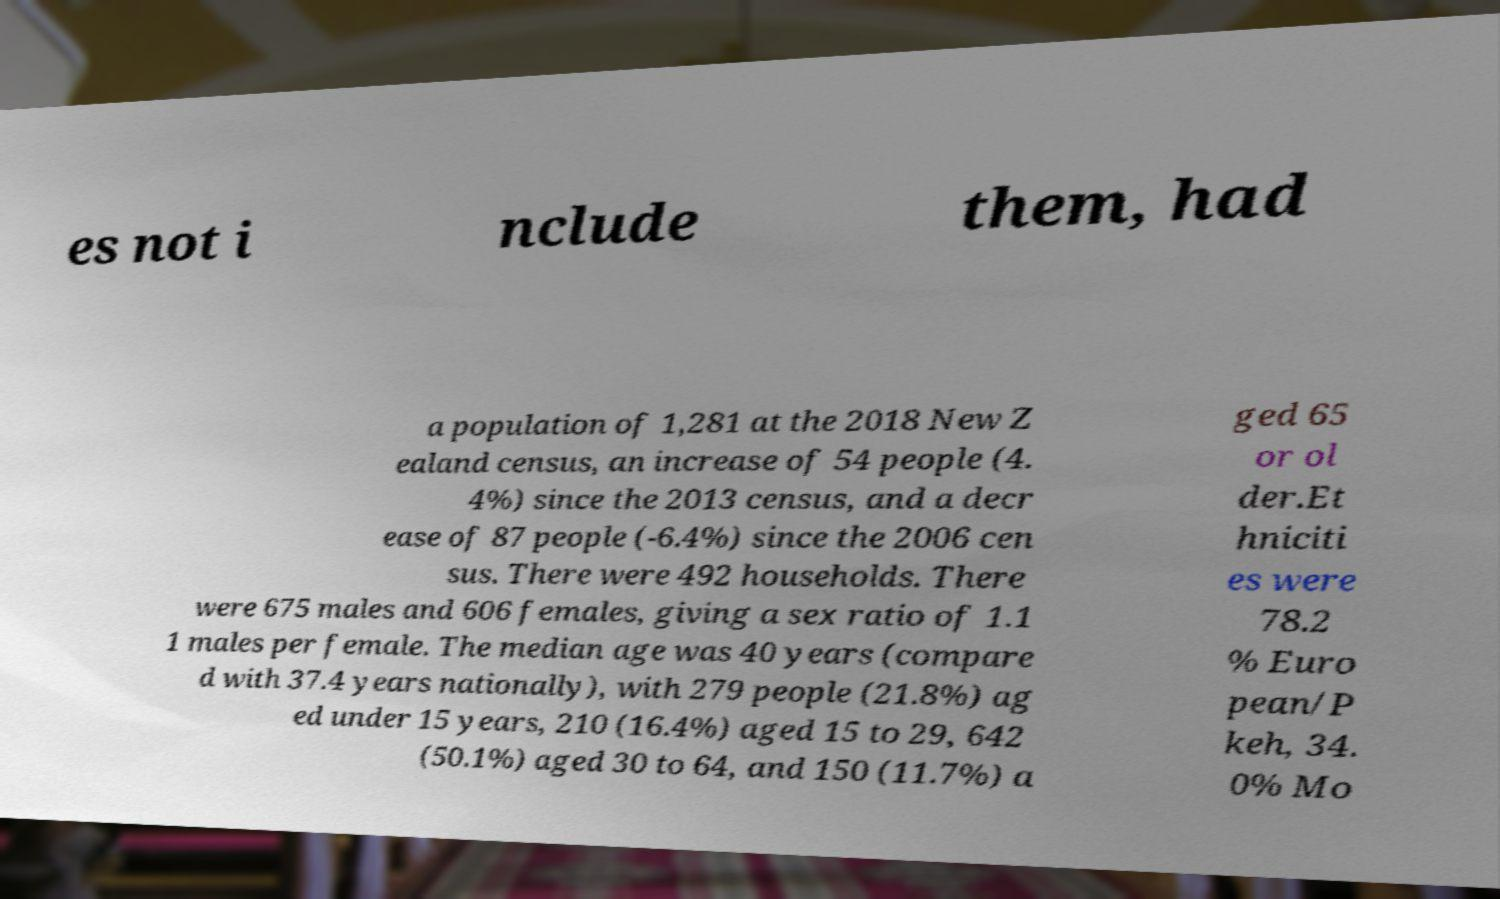Could you extract and type out the text from this image? es not i nclude them, had a population of 1,281 at the 2018 New Z ealand census, an increase of 54 people (4. 4%) since the 2013 census, and a decr ease of 87 people (-6.4%) since the 2006 cen sus. There were 492 households. There were 675 males and 606 females, giving a sex ratio of 1.1 1 males per female. The median age was 40 years (compare d with 37.4 years nationally), with 279 people (21.8%) ag ed under 15 years, 210 (16.4%) aged 15 to 29, 642 (50.1%) aged 30 to 64, and 150 (11.7%) a ged 65 or ol der.Et hniciti es were 78.2 % Euro pean/P keh, 34. 0% Mo 